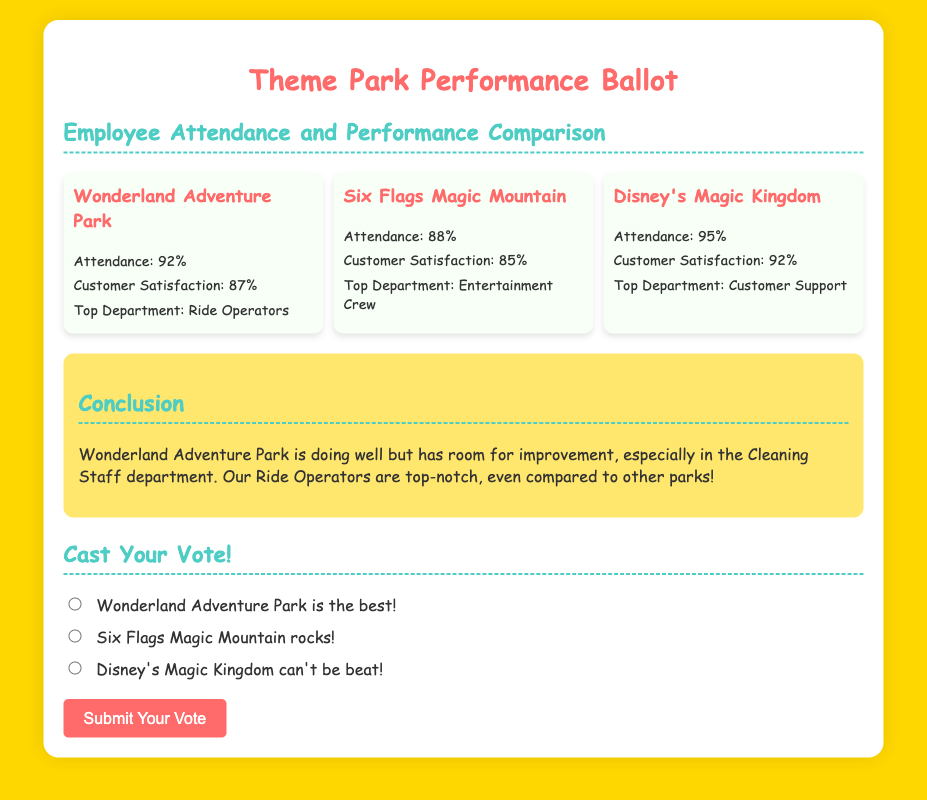What is the attendance percentage for Wonderland Adventure Park? The attendance percentage for Wonderland Adventure Park is found in the document as "Attendance: 92%."
Answer: 92% Who has the highest customer satisfaction? The park with the highest customer satisfaction can be determined from the customer satisfaction ratings, which show Disney's Magic Kingdom has "Customer Satisfaction: 92%."
Answer: Disney's Magic Kingdom What is the top department in Six Flags Magic Mountain? The document states that Six Flags Magic Mountain's top department is "Entertainment Crew."
Answer: Entertainment Crew Which park is compared to Wonderland Adventure Park for their ride operators? The document shows a comparison of parks, specifically indicating how Wonderland Adventure Park's Ride Operators perform against those in competing parks.
Answer: Six Flags Magic Mountain What color is the background of the document? The document's background color is mentioned at the beginning of the style section as "#FFD700."
Answer: Gold What was the conclusion about Wonderland Adventure Park's cleaning staff? The conclusion indicates a note about the cleaning staff needing improvement, expressed in the sentence, "but has room for improvement, especially in the Cleaning Staff department."
Answer: Room for improvement Which park has a lower attendance than Wonderland Adventure Park? Based on the attendance percentages given, Six Flags Magic Mountain has "Attendance: 88%," which is lower than Wonderland Adventure Park's.
Answer: Six Flags Magic Mountain What is the main purpose of the document? The primary aim of the document is reflected in the title, which is to gather votes on theme park performance during the month, specifically focusing on employee attendance and performance.
Answer: Cast Your Vote! 